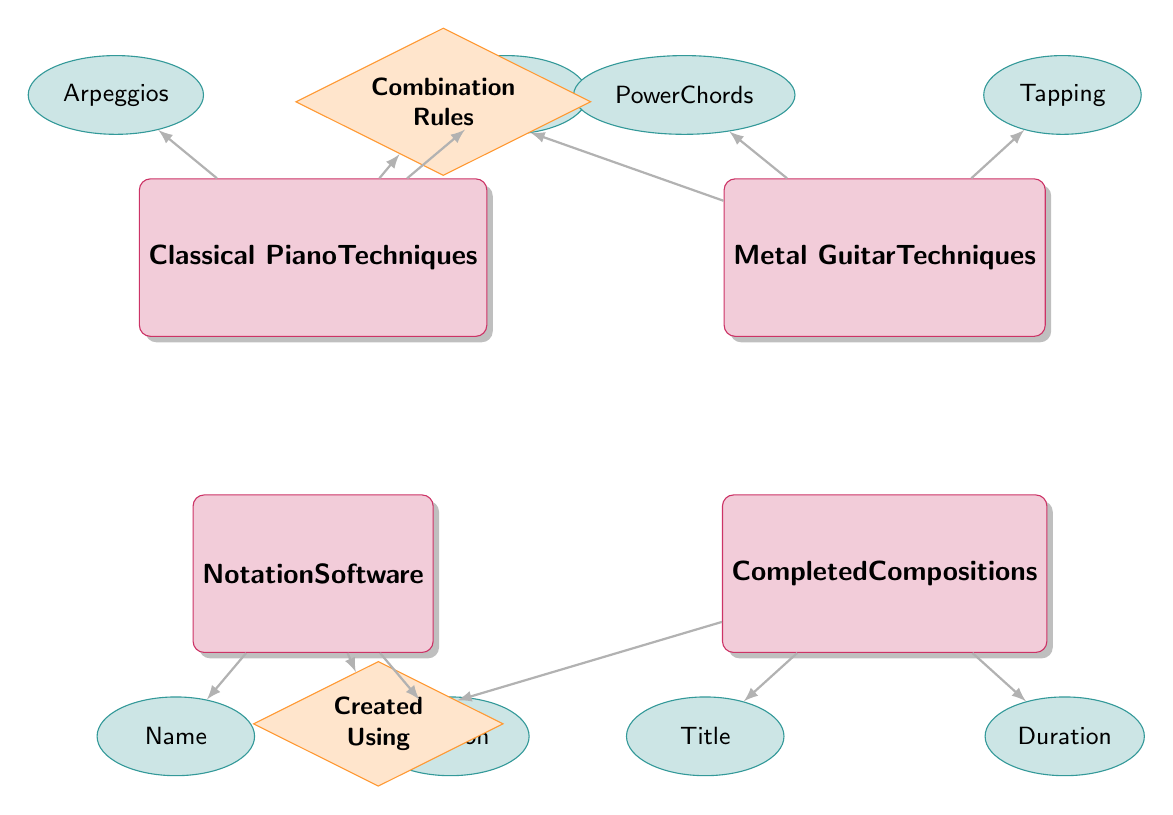What entities are included in the diagram? The diagram shows four entities: Classical Piano Techniques, Metal Guitar Techniques, Notation Software, and Completed Compositions.
Answer: Classical Piano Techniques, Metal Guitar Techniques, Notation Software, Completed Compositions How many attributes does the Classical Piano Techniques entity have? The Classical Piano Techniques entity has four attributes: Arpeggios, Scales, Pedalling, and Dynamics. Thus, the total is four.
Answer: 4 What is the relationship between Classical Piano Techniques and Metal Guitar Techniques? The relationship between Classical Piano Techniques and Metal Guitar Techniques is identified by "Combination Rules." This relationship describes how techniques from both genres blend together.
Answer: Combination Rules What attributes are associated with Notation Software? The Notation Software entity has two attributes: Name and Version. These attributes provide specific details about the software used for composition.
Answer: Name, Version How many relationships are present in the diagram? The diagram depicts two relationships: "Combination Rules" and "Created Using." Therefore, the total count of relationships is two.
Answer: 2 Which entity is connected to the Completed Compositions entity? The Completed Compositions entity is directly connected to the Notation Software entity through the "Created Using" relationship.
Answer: Notation Software What does the attribute "RuleDescription" pertain to? The attribute "RuleDescription" is associated with the relationship "Combination Rules," and it defines how Classical Piano Techniques and Metal Guitar Techniques are combined.
Answer: Combination Rules Which attributes are shown for Completed Compositions? The Completed Compositions entity includes two attributes: Title and Duration. These attributes provide information on the composition itself.
Answer: Title, Duration What is the direction of the "Created Using" relationship? The "Created Using" relationship shows a direction from Completed Compositions to Notation Software, indicating that compositions are created using specific software.
Answer: Completed Compositions to Notation Software Which technique from the Classical Piano Techniques is mentioned first in the diagram? The first technique listed under Classical Piano Techniques in the diagram is "Arpeggios." It is shown as the first attribute connected to that entity.
Answer: Arpeggios 